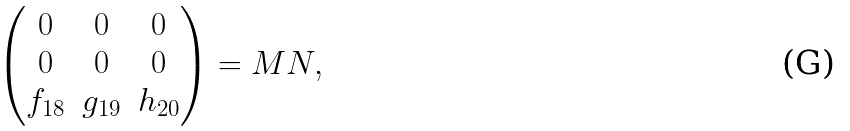Convert formula to latex. <formula><loc_0><loc_0><loc_500><loc_500>\begin{pmatrix} 0 & 0 & 0 \\ 0 & 0 & 0 \\ f _ { 1 8 } & g _ { 1 9 } & h _ { 2 0 } \\ \end{pmatrix} = M N ,</formula> 